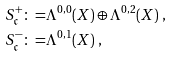Convert formula to latex. <formula><loc_0><loc_0><loc_500><loc_500>S ^ { + } _ { \mathfrak { c } } \colon = & \Lambda ^ { 0 , 0 } ( X ) \oplus \Lambda ^ { 0 , 2 } ( X ) \ , \\ S ^ { - } _ { \mathfrak { c } } \colon = & \Lambda ^ { 0 , 1 } ( X ) \ ,</formula> 